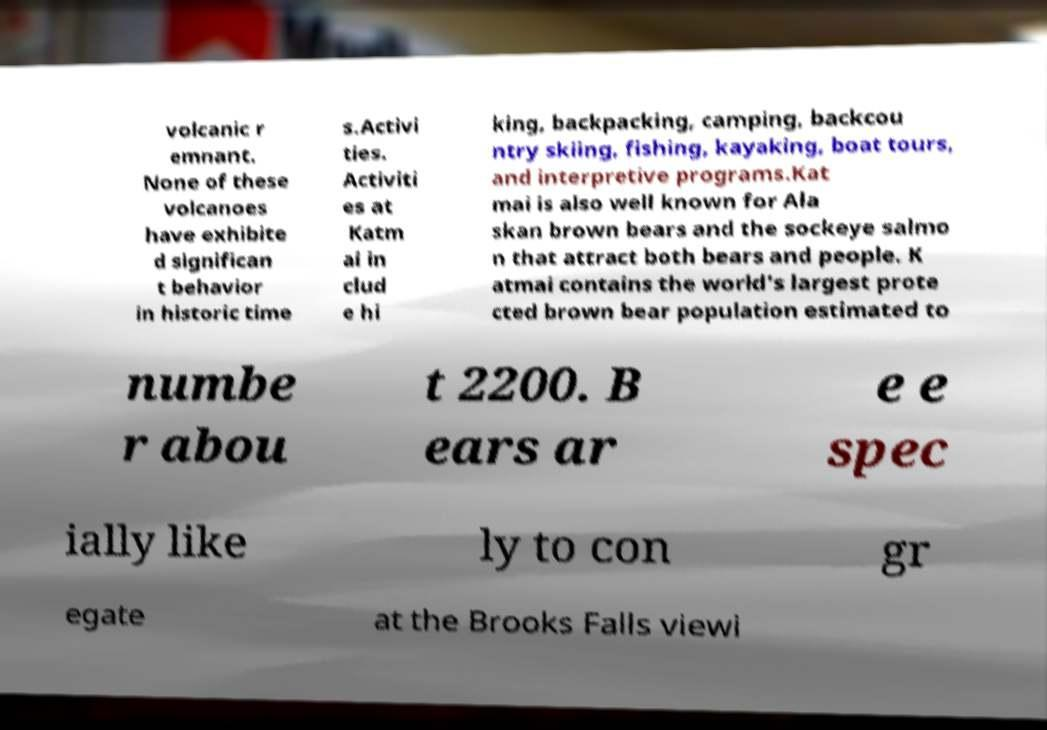For documentation purposes, I need the text within this image transcribed. Could you provide that? volcanic r emnant. None of these volcanoes have exhibite d significan t behavior in historic time s.Activi ties. Activiti es at Katm ai in clud e hi king, backpacking, camping, backcou ntry skiing, fishing, kayaking, boat tours, and interpretive programs.Kat mai is also well known for Ala skan brown bears and the sockeye salmo n that attract both bears and people. K atmai contains the world's largest prote cted brown bear population estimated to numbe r abou t 2200. B ears ar e e spec ially like ly to con gr egate at the Brooks Falls viewi 